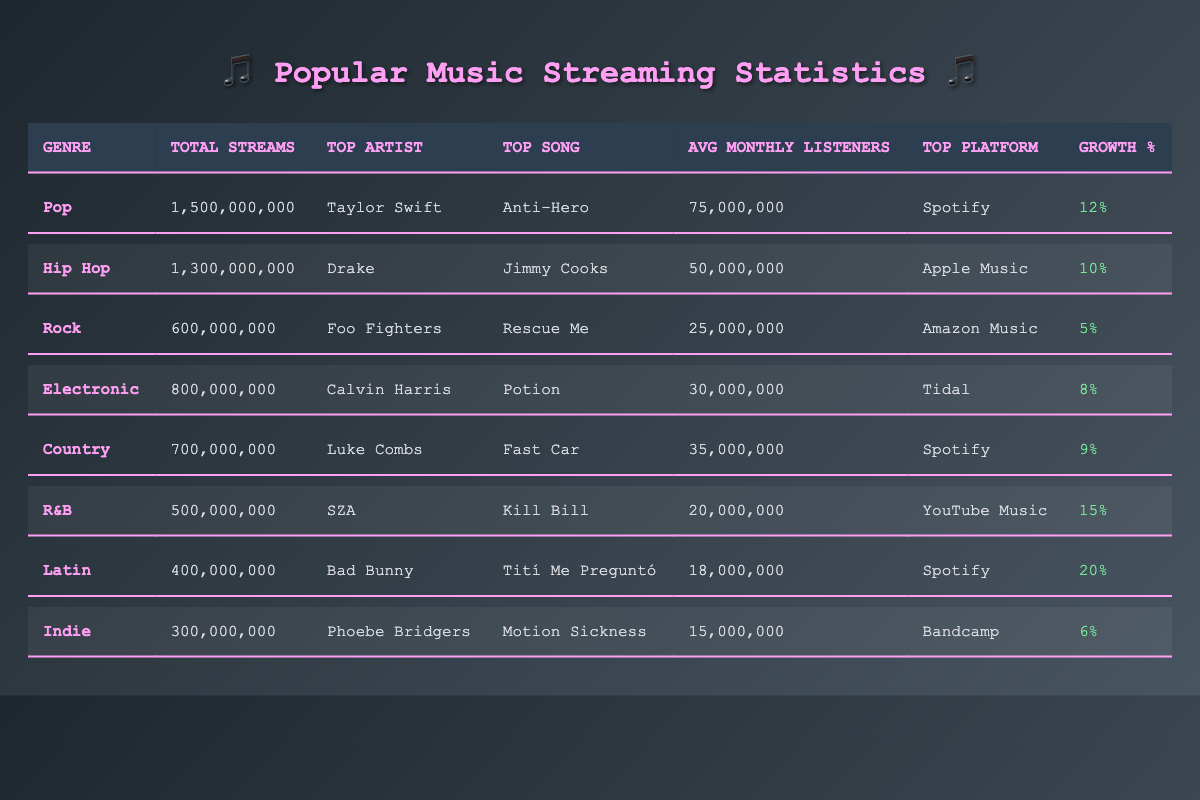What is the total number of streams for the Pop genre? The table indicates that the total number of streams for the Pop genre is 1,500,000,000, as seen directly in the relevant row for Pop.
Answer: 1,500,000,000 Who is the top artist in the R&B genre? The row for the R&B genre lists SZA as the top artist, making it easy to identify from the table.
Answer: SZA Which genre has the highest growth percentage? By observing the growth percentages for each genre, Latin has the highest at 20%, as noted in its corresponding row.
Answer: 20% What is the top song in the Hip Hop genre? The Hip Hop genre row shows that the top song is "Jimmy Cooks," which can be found in the relevant column.
Answer: Jimmy Cooks How many average monthly listeners does the Country genre have? The Country genre row states that it has 35,000,000 average monthly listeners, which is easily identifiable in the table.
Answer: 35,000,000 What is the difference in total streams between Pop and R&B genres? The total streams for Pop are 1,500,000,000 and for R&B are 500,000,000. The difference is calculated as 1,500,000,000 - 500,000,000 = 1,000,000,000.
Answer: 1,000,000,000 Which genre has the least total streams? Looking through the total streams for each genre, Indie has the least at 300,000,000 streams, as seen in the last row of the table.
Answer: Indie Is the top platform for Country genre Spotify? Referring to the Country genre row, it clearly lists Spotify as the top platform, making the statement true.
Answer: Yes What is the average number of monthly listeners across all genres? The average is calculated by adding all the average monthly listeners (75,000,000 + 50,000,000 + 25,000,000 + 30,000,000 + 35,000,000 + 20,000,000 + 18,000,000 + 15,000,000 =  253,000,000) and dividing by the number of genres (8). The average equals 31,625,000.
Answer: 31,625,000 How does the total streams of Electronic compare to Rock? The total streams for Electronic is 800,000,000 and for Rock is 600,000,000. Electronic has 200,000,000 more streams than Rock, which is calculated by 800,000,000 - 600,000,000.
Answer: 200,000,000 more 